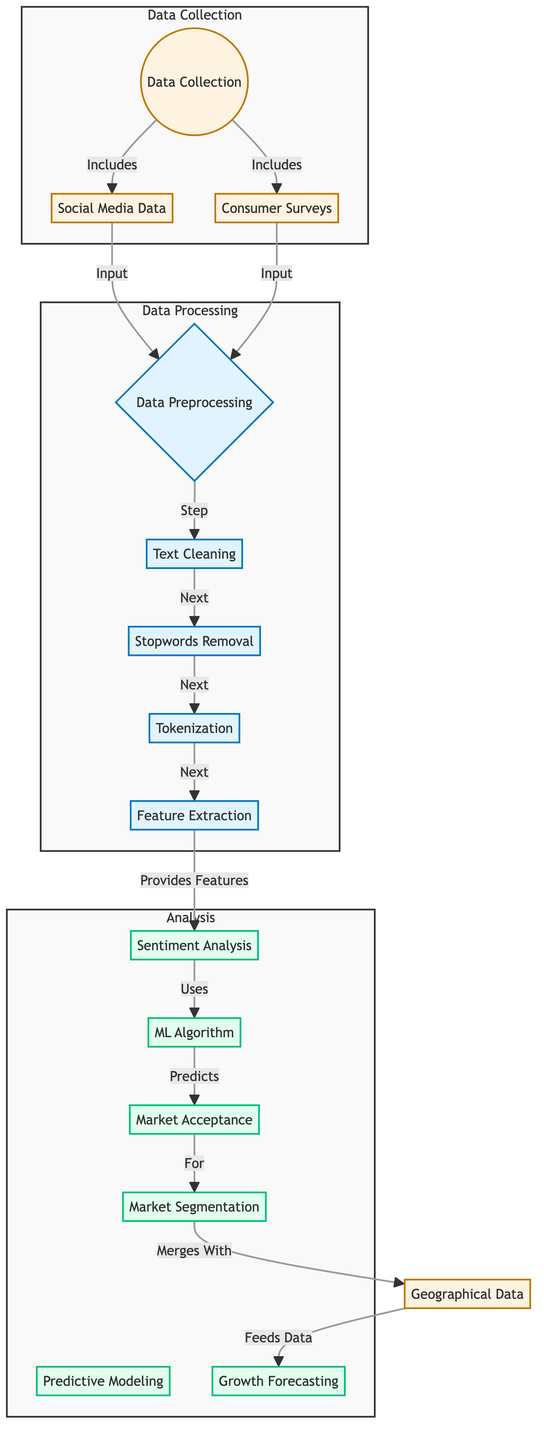What are the types of data collected? The diagram outlines two types of data collected: social media data and consumer surveys, which are listed under the Data Collection section.
Answer: Social media data and consumer surveys What is the first step in data preprocessing? The flow from Data Collection to Data Preprocessing shows that the first process step is text cleaning, coming right after collecting the data.
Answer: Text cleaning How many processes are involved in data preprocessing? In the Data Processing subgraph, there are four distinct processes: text cleaning, stopwords removal, tokenization, and feature extraction.
Answer: Four What analysis follows sentiment analysis? The diagram indicates that sentiment analysis connects to the machine learning algorithm, suggesting that the next step is using the machine learning algorithm to predict market acceptance.
Answer: Machine learning algorithm Which node merges with market segmentation? According to the flow, market acceptance merges with market segmentation to further analyze and refine the data concerning consumer sentiment and preferences.
Answer: Geographical data What is the purpose of feature extraction? The purpose of feature extraction, as indicated in the flow, is to provide features necessary for the subsequent sentiment analysis process to occur.
Answer: Provide features Which analysis directly predicts market acceptance? The machine learning algorithm is specifically identified in the diagram as the analysis that directly predicts market acceptance based on the processed data and sentiment analysis.
Answer: Machine learning algorithm What does growth forecasting depend on? Growth forecasting depends on the merged data from market segmentation and geographical data to make informed predictions about market growth potential for edible insects.
Answer: Merged data from market segmentation and geographical data How many nodes are in the Data Processing subgraph? The Data Processing subgraph consists of four nodes: data preprocessing, text cleaning, stopwords removal, and tokenization.
Answer: Four nodes 